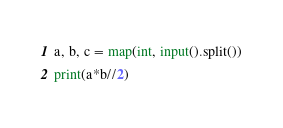Convert code to text. <code><loc_0><loc_0><loc_500><loc_500><_Python_>a, b, c = map(int, input().split())
print(a*b//2)</code> 